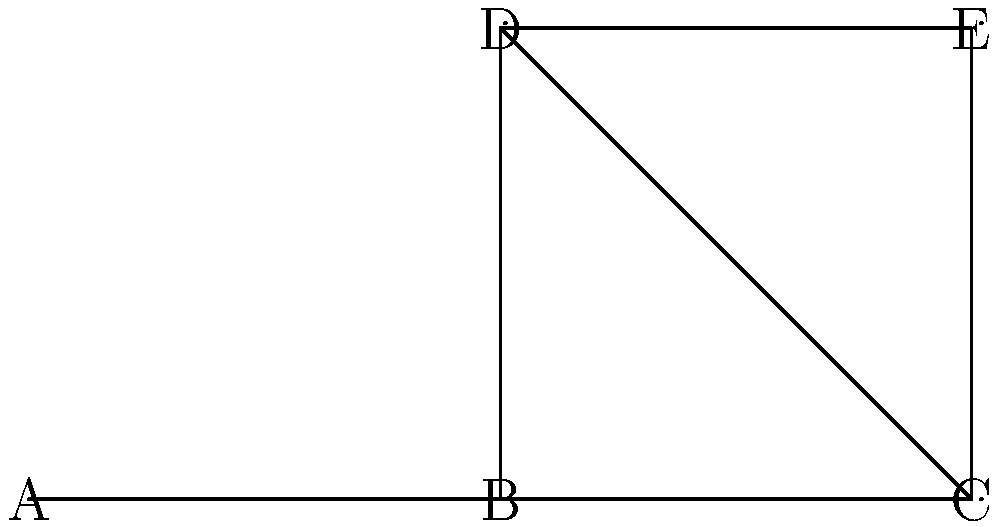You're helping your neighbor understand their house layout for potential repairs. Given the graph representation of their house where nodes represent rooms and edges represent connections between rooms, which room has the highest degree centrality and would be considered the most central in terms of accessibility? To solve this problem, we need to follow these steps:

1. Understand degree centrality:
   Degree centrality is a measure of the number of direct connections a node has to other nodes in the graph.

2. Count the connections (degree) for each room:
   Room A: 1 connection
   Room B: 3 connections
   Room C: 3 connections
   Room D: 2 connections
   Room E: 2 connections

3. Identify the room(s) with the highest number of connections:
   Rooms B and C both have the highest degree centrality with 3 connections each.

4. Consider the context:
   In terms of accessibility and centrality in a house layout, room B appears to be more central as it connects to rooms A, C, and D, providing access to different areas of the house.

Therefore, room B would be considered the most central room in terms of accessibility based on degree centrality.
Answer: Room B 